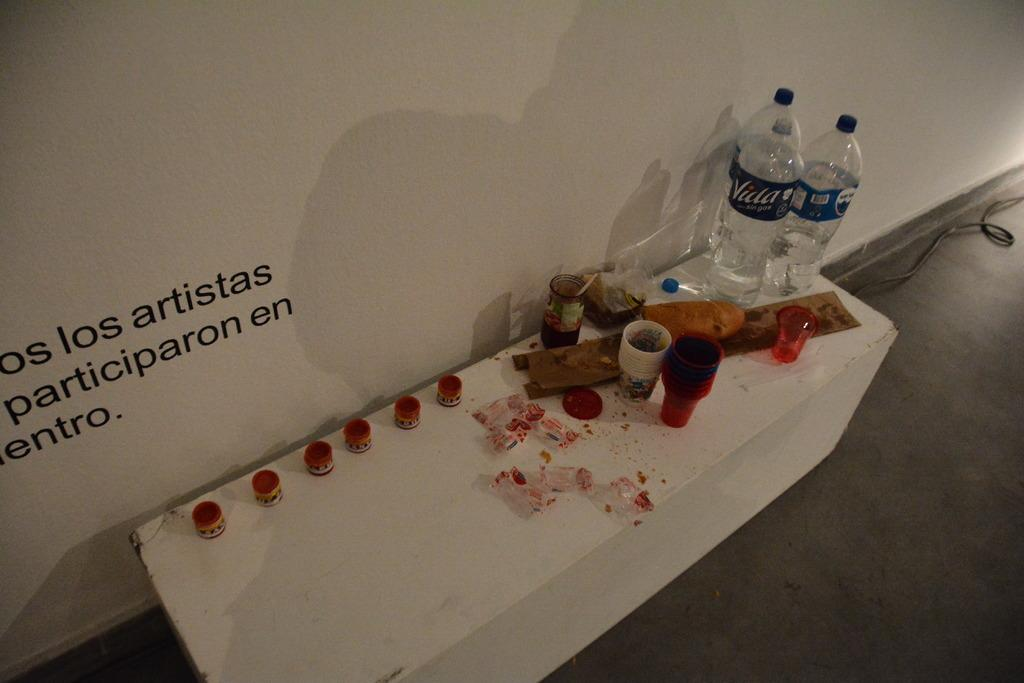<image>
Summarize the visual content of the image. Table with bottles of Villa water and some food as well. 